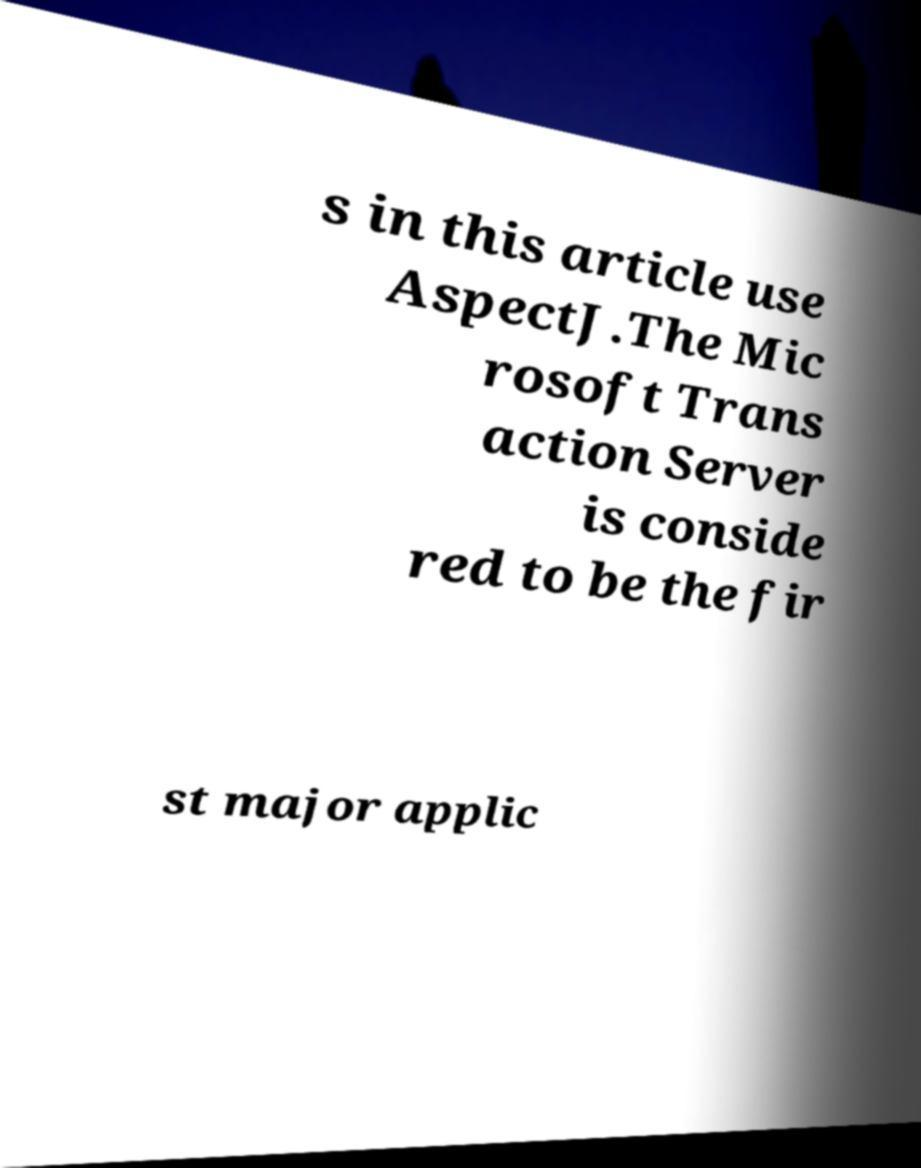Could you extract and type out the text from this image? s in this article use AspectJ.The Mic rosoft Trans action Server is conside red to be the fir st major applic 